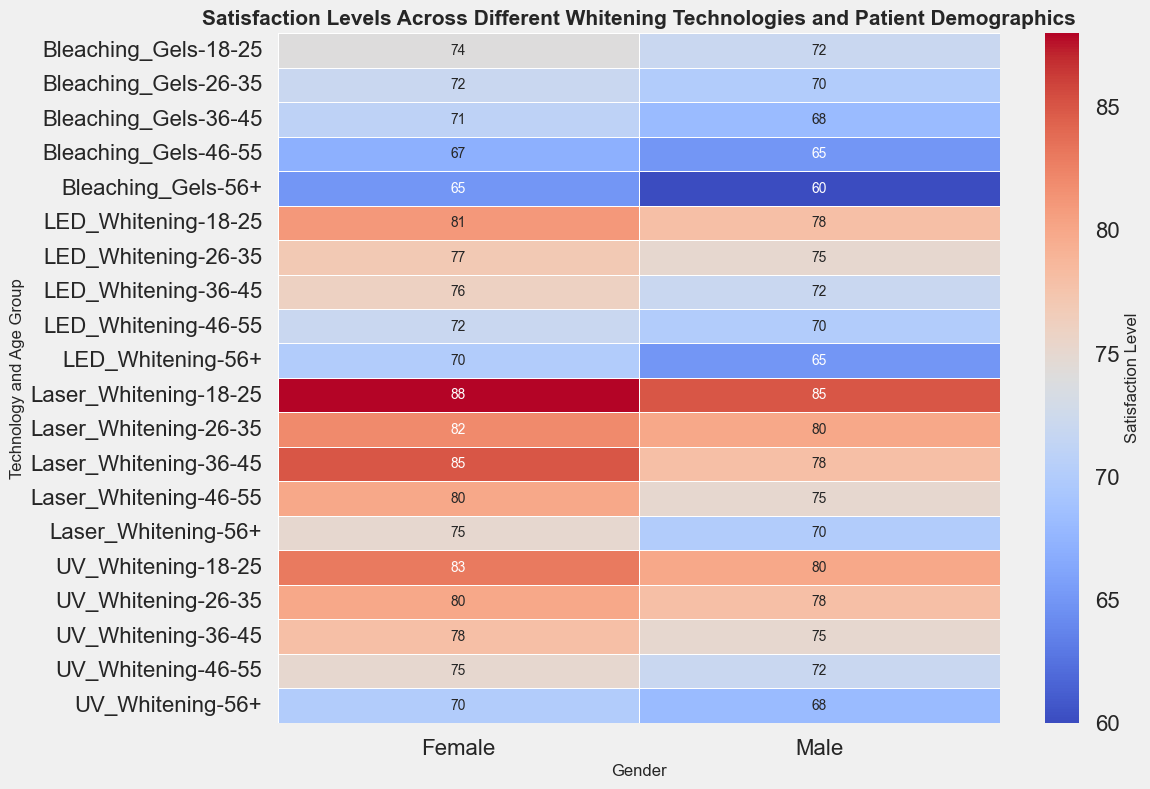What's the satisfaction level for females aged 18-25 using Laser Whitening? Look at the intersection of the 'Laser Whitening' technology and '18-25' age group row with the 'Female' column. The value at this intersection is the satisfaction level.
Answer: 88 Which technology has the highest satisfaction level for males aged 36-45? Compare the satisfaction levels for males aged 36-45 across different technologies. Laser Whitening has a satisfaction level of 78, LED Whitening 72, Bleaching Gels 68, and UV Whitening 75. The highest value is for Laser Whitening.
Answer: Laser Whitening Between males aged 46-55 and females aged 46-55, who has a higher satisfaction level for UV Whitening? Compare the satisfaction levels for males and females aged 46-55 using UV Whitening. Males have a satisfaction level of 72 and females 75. Females have a higher satisfaction level.
Answer: Females What is the overall satisfaction range for UV Whitening across all age groups and genders? Identify the minimum and maximum satisfaction levels for UV Whitening. The range spans from the lowest value to the highest value observed. The satisfaction levels vary from 68 (males 56+) to 83 (females 18-25).
Answer: 68-83 Which age group has the least satisfaction with LED Whitening for both genders? Compare satisfaction levels across all age groups for LED Whitening. The 56+ group has the lowest values: 65 for males and 70 for females.
Answer: 56+ What is the difference in satisfaction levels between males aged 26-35 and males aged 56+ using Bleaching Gels? Subtract the satisfaction level of males aged 56+ from the satisfaction level of males aged 26-35 using Bleaching Gels. Satisfaction levels are 70 and 60, respectively. The difference is 70 - 60.
Answer: 10 Calculate the average satisfaction level for females aged 36-45 across all technologies. Add the satisfaction levels for females aged 36-45 across all technologies (Laser Whitening 85, LED Whitening 76, Bleaching Gels 71, UV Whitening 78) and divide by the number of technologies (4). The sum is 310. The average is 310/4.
Answer: 77.5 Which technology shows more consistent satisfaction levels across different age groups for females? Evaluate the variation in satisfaction levels for each technology across different age groups for females. Technologies with smaller ranges have more consistent levels. Laser Whitening varies from 75 to 88, LED Whitening from 70 to 81, Bleaching Gels from 65 to 74, UV Whitening from 70 to 83. LED Whitening has the least variation.
Answer: LED Whitening Do males aged 56+ have higher satisfaction with UV Whitening or Bleaching Gels? Compare the satisfaction levels for males aged 56+ using UV Whitening and Bleaching Gels. UV Whitening has a satisfaction level of 68, and Bleaching Gels has a level of 60.
Answer: UV Whitening 